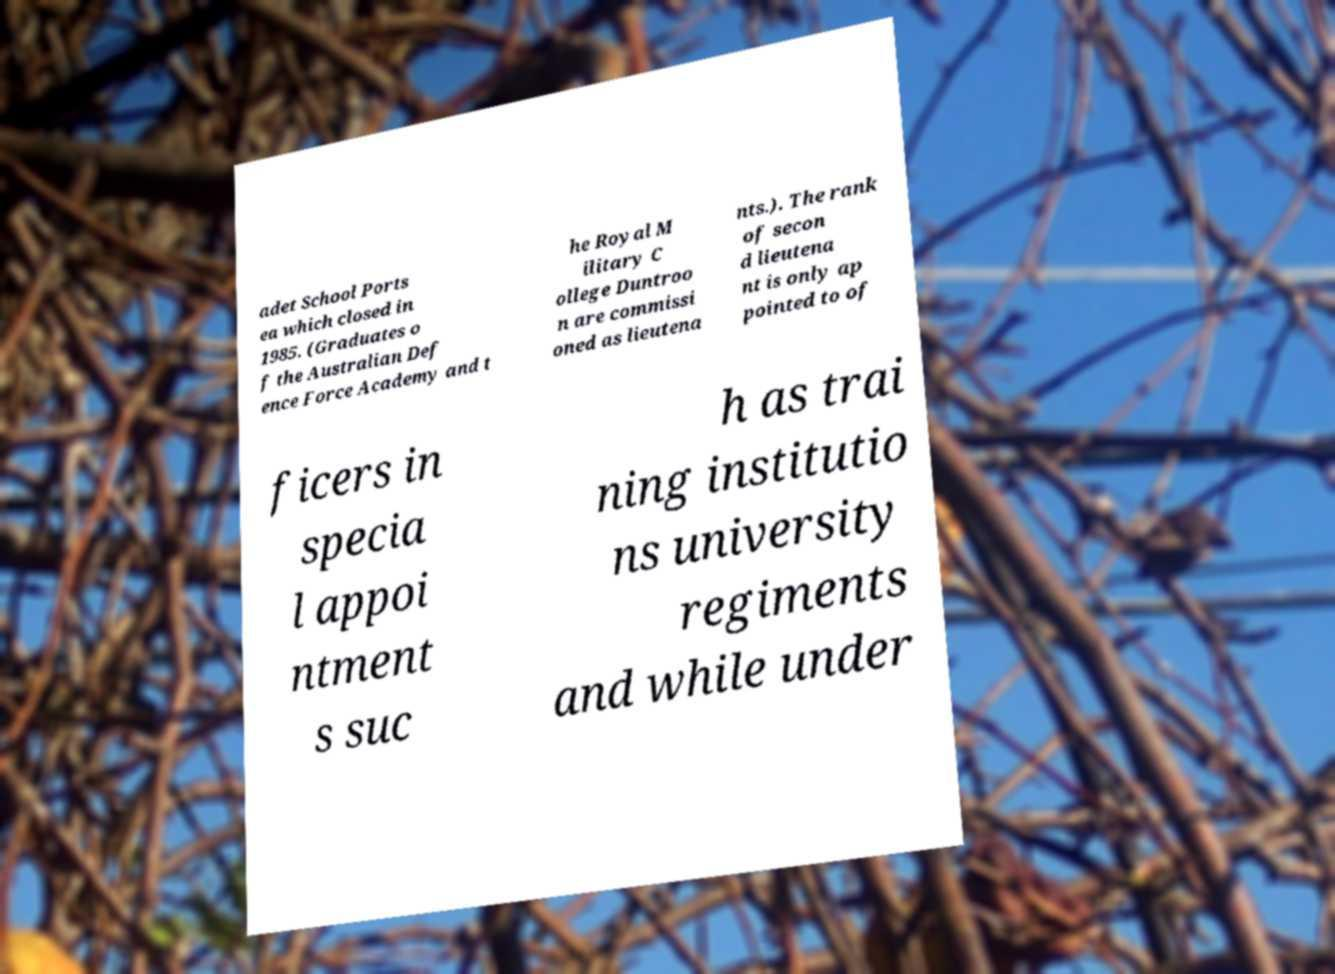Could you assist in decoding the text presented in this image and type it out clearly? adet School Ports ea which closed in 1985. (Graduates o f the Australian Def ence Force Academy and t he Royal M ilitary C ollege Duntroo n are commissi oned as lieutena nts.). The rank of secon d lieutena nt is only ap pointed to of ficers in specia l appoi ntment s suc h as trai ning institutio ns university regiments and while under 